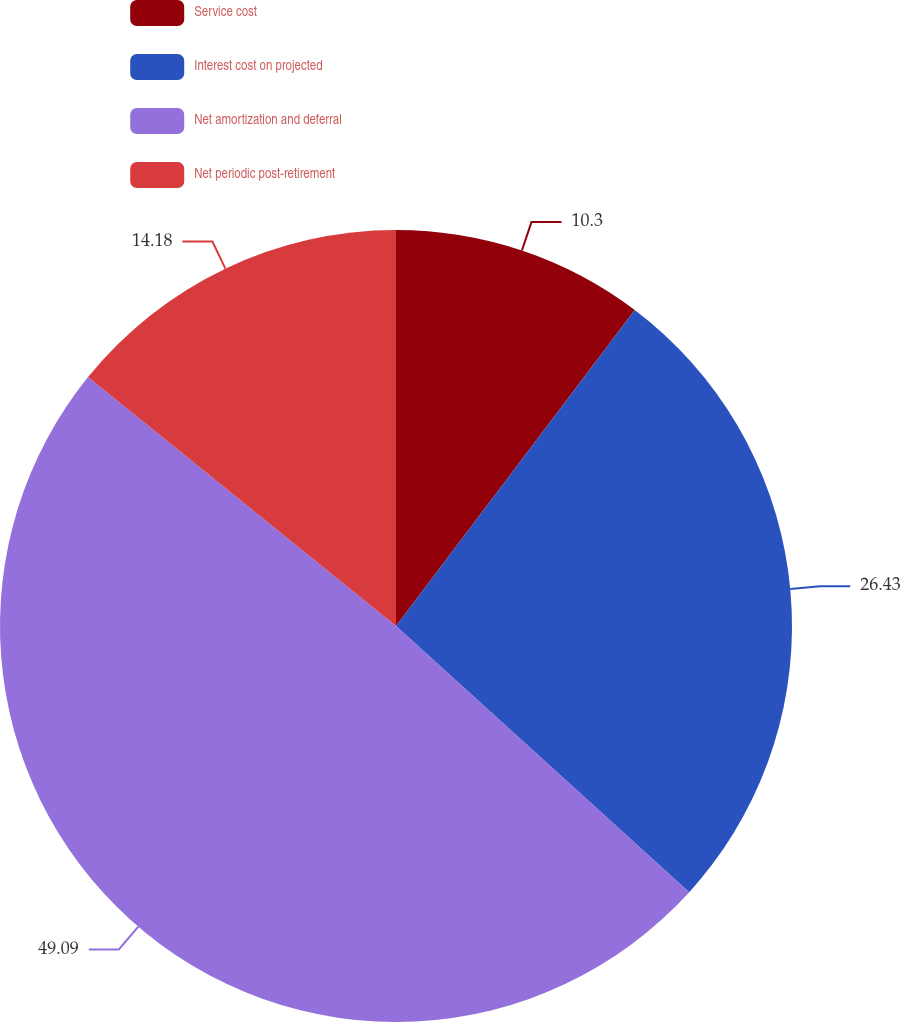Convert chart to OTSL. <chart><loc_0><loc_0><loc_500><loc_500><pie_chart><fcel>Service cost<fcel>Interest cost on projected<fcel>Net amortization and deferral<fcel>Net periodic post-retirement<nl><fcel>10.3%<fcel>26.43%<fcel>49.09%<fcel>14.18%<nl></chart> 